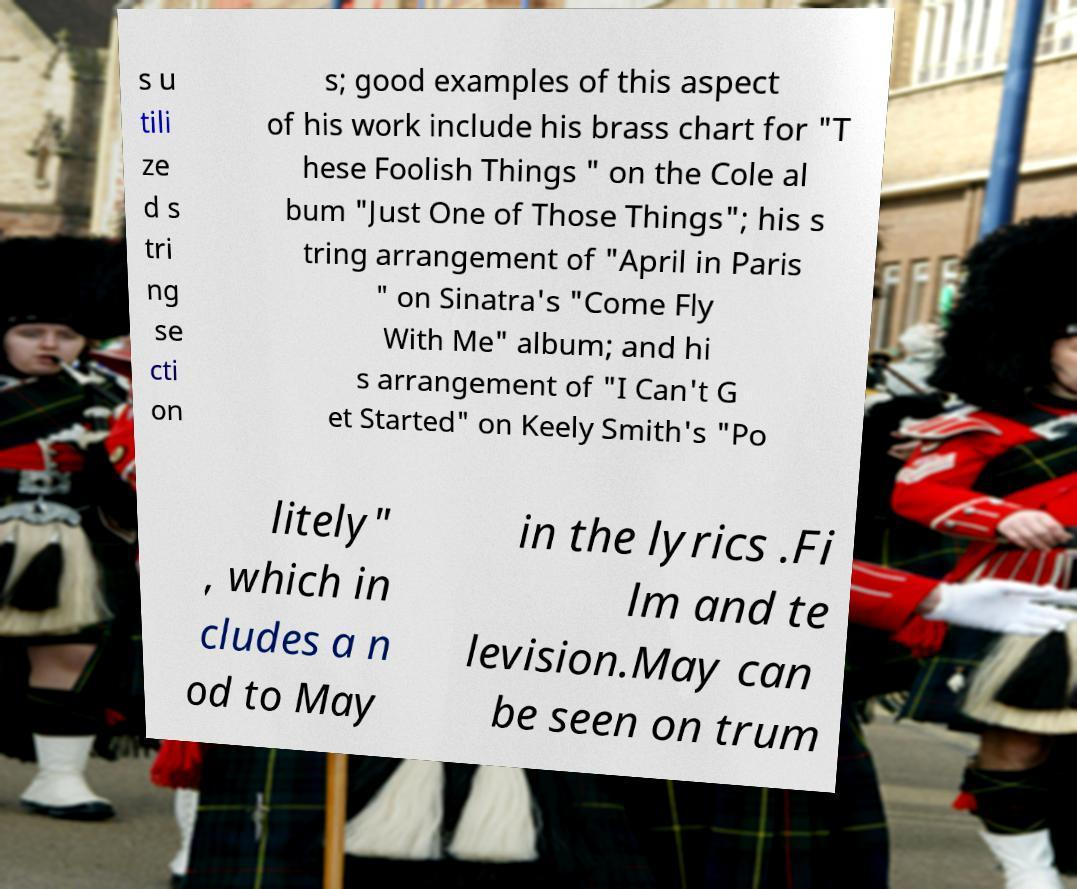Please read and relay the text visible in this image. What does it say? s u tili ze d s tri ng se cti on s; good examples of this aspect of his work include his brass chart for "T hese Foolish Things " on the Cole al bum "Just One of Those Things"; his s tring arrangement of "April in Paris " on Sinatra's "Come Fly With Me" album; and hi s arrangement of "I Can't G et Started" on Keely Smith's "Po litely" , which in cludes a n od to May in the lyrics .Fi lm and te levision.May can be seen on trum 